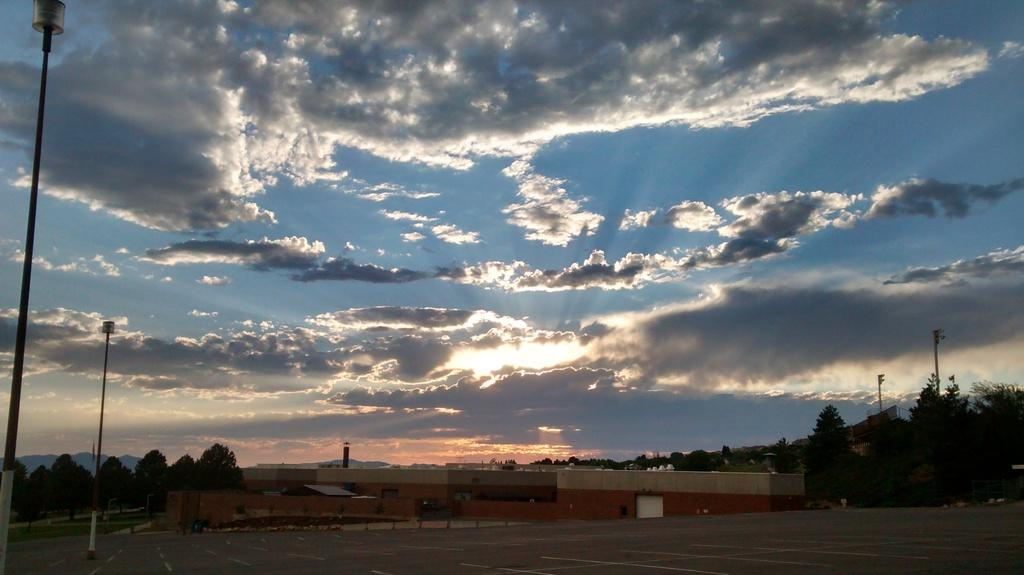What is the main feature of the image? There is a road in the image. Are there any structures near the road? Yes, there is a light pole on the road. What else can be seen in the image besides the road and light pole? There is a building in the image. What is visible in the background of the image? Trees and a cloudy sky are visible in the background of the image. How many snakes are slithering on the wall in the image? There are no snakes present in the image, and there is no wall visible. 